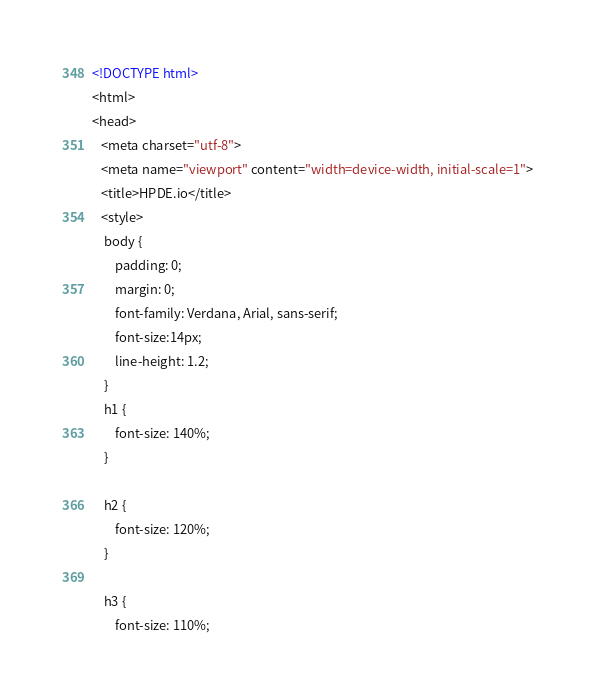<code> <loc_0><loc_0><loc_500><loc_500><_HTML_><!DOCTYPE html>
<html>
<head>
   <meta charset="utf-8">
   <meta name="viewport" content="width=device-width, initial-scale=1">
   <title>HPDE.io</title>
   <style>
	body {
		padding: 0;
		margin: 0;
		font-family: Verdana, Arial, sans-serif; 
		font-size:14px; 
		line-height: 1.2;
	}
	h1 {
		font-size: 140%;
	}

	h2 {
		font-size: 120%;
	}

	h3 {
		font-size: 110%;</code> 